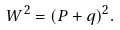Convert formula to latex. <formula><loc_0><loc_0><loc_500><loc_500>W ^ { 2 } = ( P + q ) ^ { 2 } .</formula> 